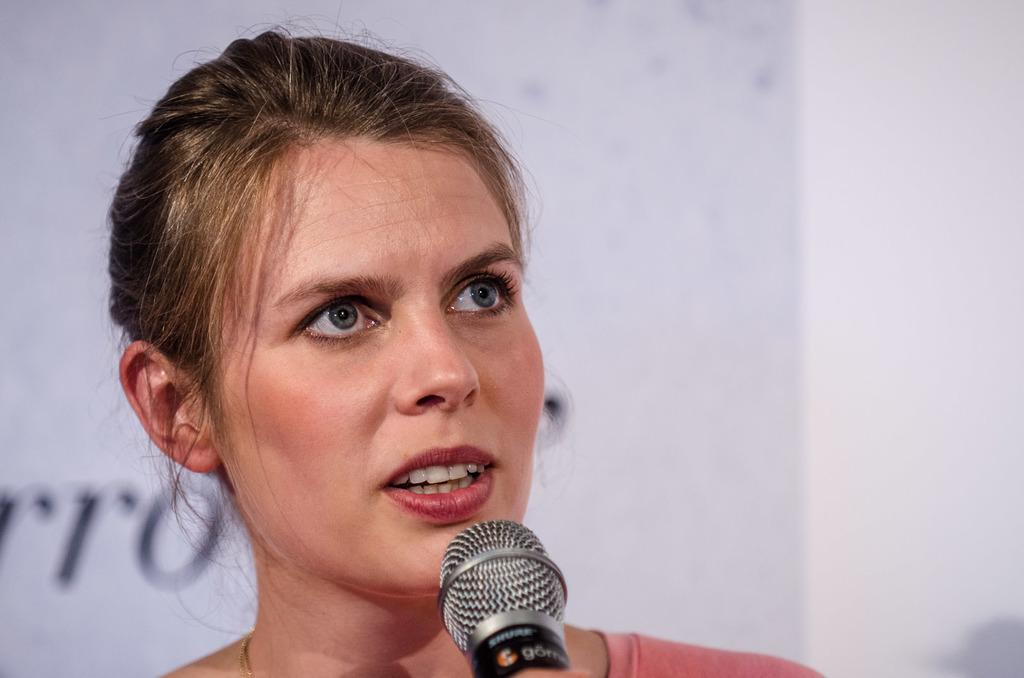Who is the main subject in the image? There is a woman in the center of the image. What is the woman holding in the image? The woman is holding a mic. What can be seen in the background of the image? There is a wall in the background of the image. What type of pan is being used in the competition in the image? There is no pan or competition present in the image; it features a woman holding a mic. What body part is the woman using to hold the mic in the image? The woman is using her hand to hold the mic in the image. 